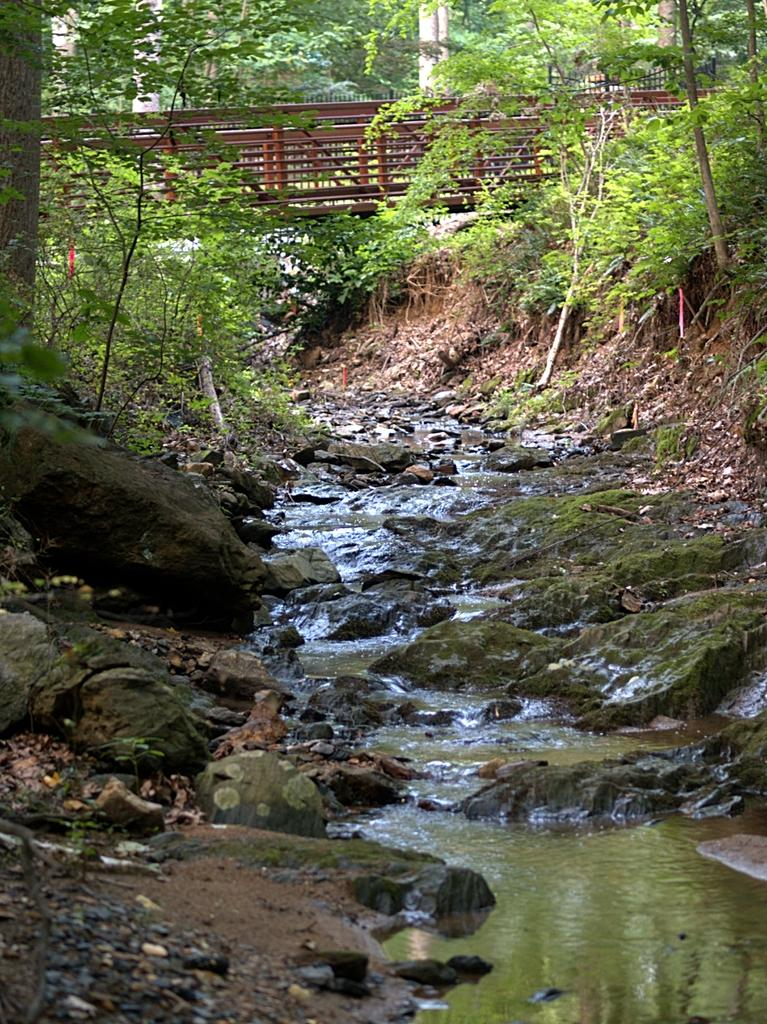What type of vegetation is present in the image? There is a group of trees in the image. What other objects can be seen in the image? There are stones and a bridge visible in the image. What is the condition of the water in the image? The water is visible in the image. What part of the trees is visible in the image? The bark of the trees is visible. What type of weather can be seen in the image? The provided facts do not mention any weather conditions, so it cannot be determined from the image. 